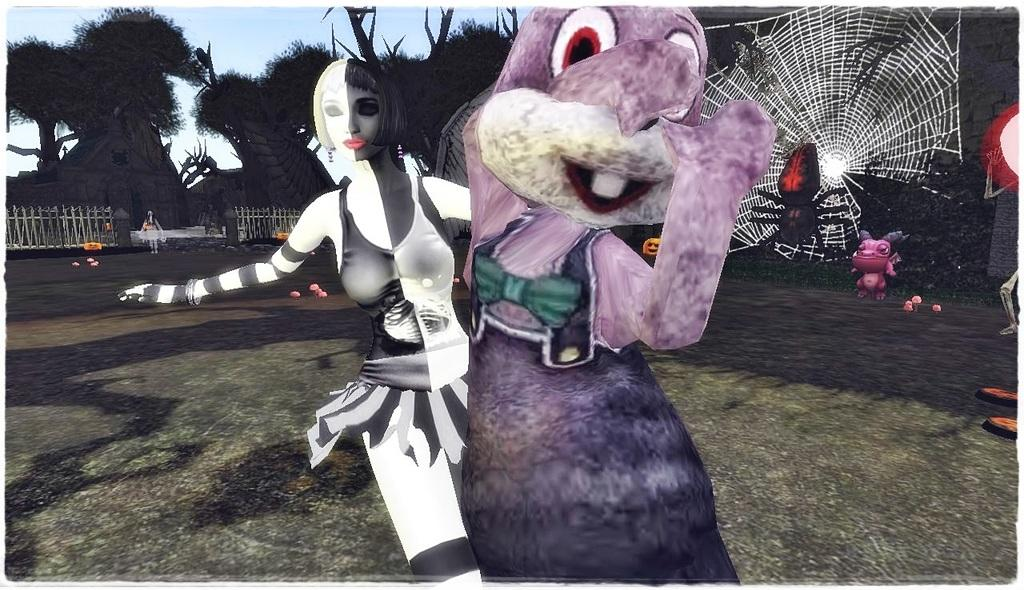What is present in the image? There is a person in the image. What else can be seen in the image besides the person? There are animated images, trees, and fencing in the image. What type of cushion is being used by the person in the image? There is no cushion present in the image. Can you describe how the person is kicking in the image? There is no indication of the person kicking in the image. 